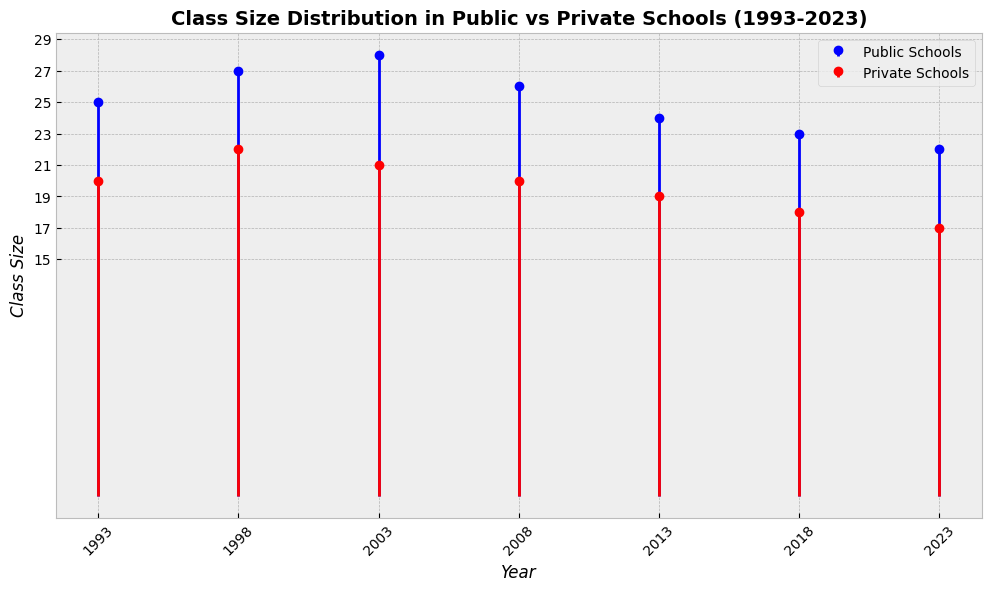Which year had the smallest average class size in public schools? To find the smallest average class size, we look at the values for public schools in each year on the stem plot. The smallest value is 22 in the year 2023.
Answer: 2023 How did the class size in public schools change from 2003 to 2023? Start by identifying the class sizes in public schools in 2003 (28) and 2023 (22). Then, calculate the change: 28 - 22 = 6. The class size decreased by 6 students over these years.
Answer: Decreased by 6 students What is the pattern of class sizes in private schools from 1993 to 2023? Identify the class sizes in private schools for each year: 1993 (20), 1998 (22), 2003 (21), 2008 (20), 2013 (19), 2018 (18), and 2023 (17). We observe that the class sizes show a general downward trend over the years.
Answer: Downward trend Which type of schools had consistently smaller class sizes from 1993 to 2023? Compare class sizes for public and private schools for each year. In all years, private schools have smaller class sizes: e.g., in 1993, public (25) vs. private (20), and in 2023, public (22) vs. private (17).
Answer: Private schools What is the largest class size observed for private schools? Look at the data points for private schools on the stem plot. The largest class size is 22 in 1998.
Answer: 22 On average, how much did the class size decrease per decade in private schools from 1993 to 2023? Calculate the total decrease in class size for private schools from 1993 (20) to 2023 (17): 20 - 17 = 3. There are three decades, so the average decrease per decade is 3 / 3 = 1.
Answer: 1 student per decade In which decade was there the most significant decrease in class sizes in public schools? Calculate the decreases for each decade: 1993-2003 (25 to 28, +3), 2003-2013 (28 to 24, -4), and 2013-2023 (24 to 22, -2). The most significant decrease is in the 2003-2013 decade.
Answer: 2003-2013 How does the class size in public schools in 2023 compare to that in private schools in 1993? Compare the class sizes: public schools in 2023 (22) and private schools in 1993 (20). Public schools in 2023 have a larger class size than private schools in 1993.
Answer: Public schools in 2023 have larger class sizes What's the overall trend in class sizes for public schools from 1993 to 2023? Identify the class sizes for each year: 1993 (25), 1998 (27), 2003 (28), 2008 (26), 2013 (24), 2018 (23), and 2023 (22). The trend shows a peak around 2003 followed by a general decrease.
Answer: Decrease after peaking around 2003 What is the difference in average class size between public and private schools in 2023? Identify the class sizes for 2023: public schools (22) and private schools (17). The difference is 22 - 17 = 5.
Answer: 5 students 